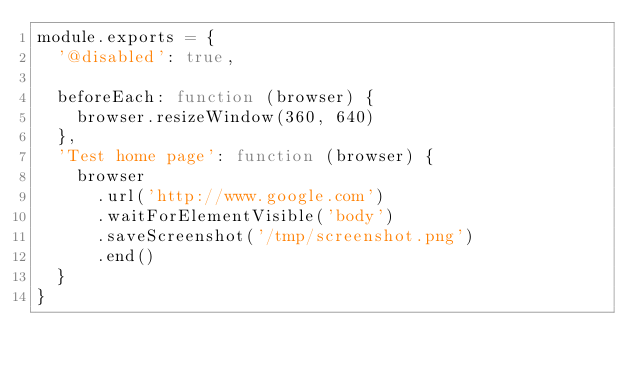Convert code to text. <code><loc_0><loc_0><loc_500><loc_500><_JavaScript_>module.exports = {
  '@disabled': true,

  beforeEach: function (browser) {
    browser.resizeWindow(360, 640)
  },
  'Test home page': function (browser) {
    browser
      .url('http://www.google.com')
      .waitForElementVisible('body')
      .saveScreenshot('/tmp/screenshot.png')
      .end()
  }
}
</code> 